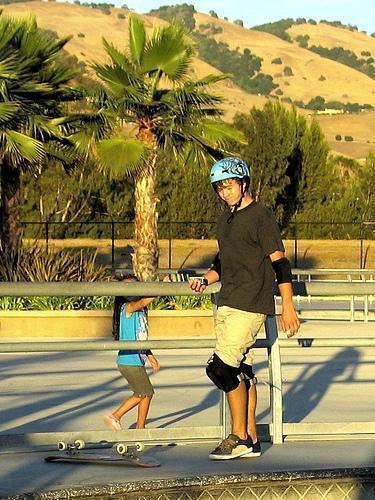What kind of palm tree is in the center of this photo?
Choose the right answer from the provided options to respond to the question.
Options: Queen palm, fishtail palm, fan palm, sago palm. Fan palm. 